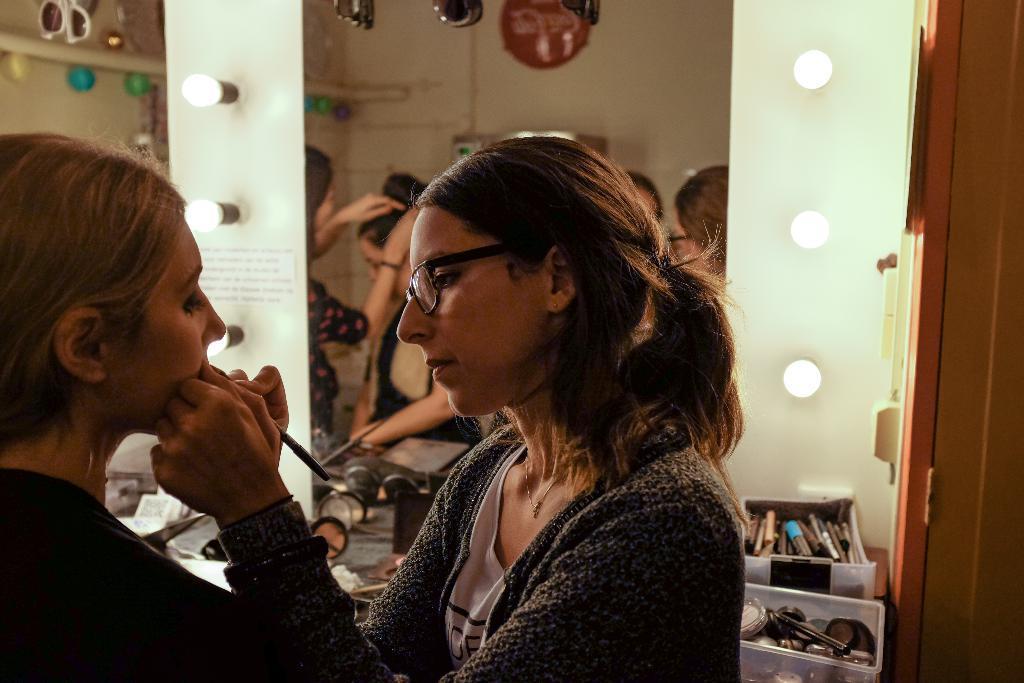Could you give a brief overview of what you see in this image? On the left side of the image there is a lady. In front of her there is a lady with spectacles. Behind them there are boxes with makeup kit and some other things. In the background on the wall there are bulbs and mirrors. On the mirrors there is a reflection of few people and some other things. On the right side of the image there is a wall with a door. 